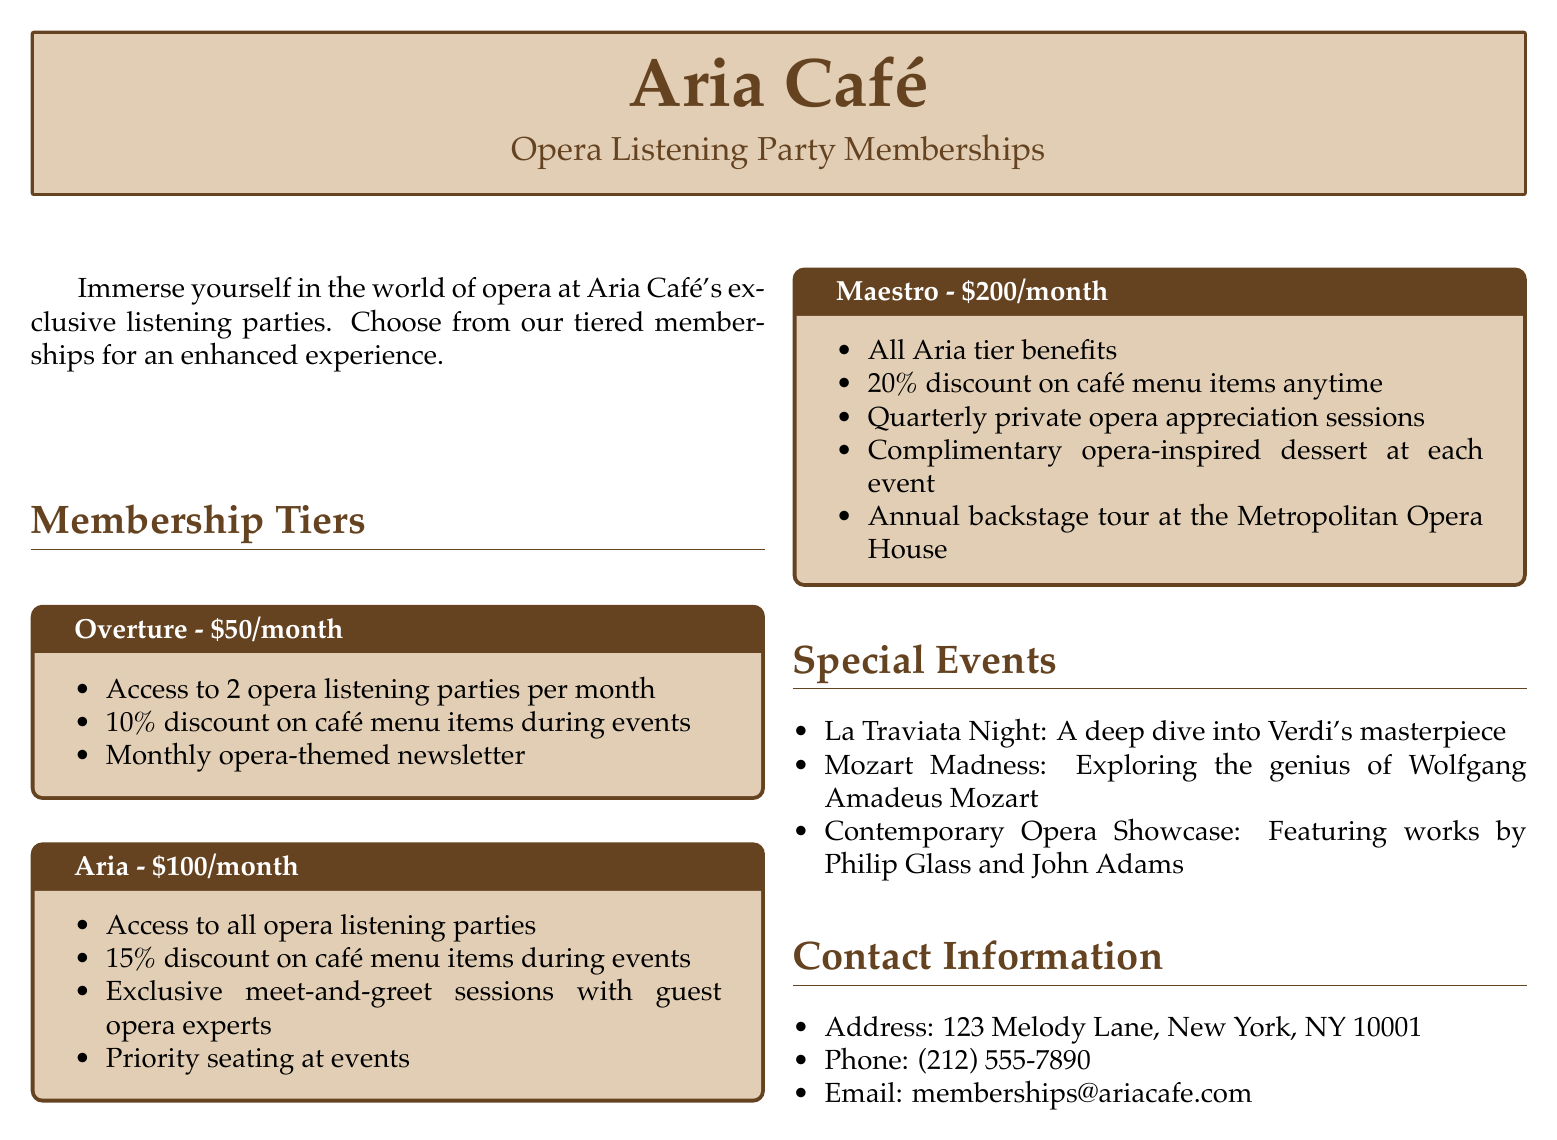What is the name of the café? The name of the café is mentioned at the top of the document.
Answer: Aria Café How many opera listening parties can Overture members attend per month? The document specifies the number of events for each membership tier.
Answer: 2 What is the discount percentage for Aria members on café menu items during events? The discount percentage offered to Aria members is listed under their benefits.
Answer: 15% What is one benefit exclusive to Maestro members? The document lists specific benefits for each membership tier, unique to Maestro members.
Answer: Annual backstage tour at the Metropolitan Opera House What is the membership fee for the Aria tier? The fee for the Aria membership tier is clearly stated in the document.
Answer: $100/month What special event focuses on Verdi's work? The document lists several special events, including the one focused on Verdi.
Answer: La Traviata Night How often do Maestro members receive a discount on café menu items? The discount frequency is stated in the benefits of the Maestro tier.
Answer: Anytime What is the email address for membership inquiries? Contact information, including the email, is provided in the document.
Answer: memberships@ariacafe.com 